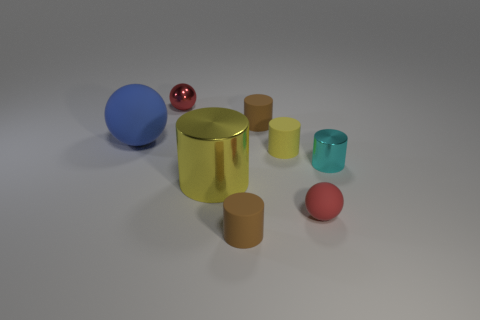Subtract all big matte balls. How many balls are left? 2 Add 1 tiny metallic objects. How many objects exist? 9 Subtract 1 spheres. How many spheres are left? 2 Subtract all cyan cylinders. How many cylinders are left? 4 Subtract all large things. Subtract all small cyan cylinders. How many objects are left? 5 Add 3 yellow rubber cylinders. How many yellow rubber cylinders are left? 4 Add 4 tiny metallic cylinders. How many tiny metallic cylinders exist? 5 Subtract 0 brown blocks. How many objects are left? 8 Subtract all balls. How many objects are left? 5 Subtract all gray balls. Subtract all cyan blocks. How many balls are left? 3 